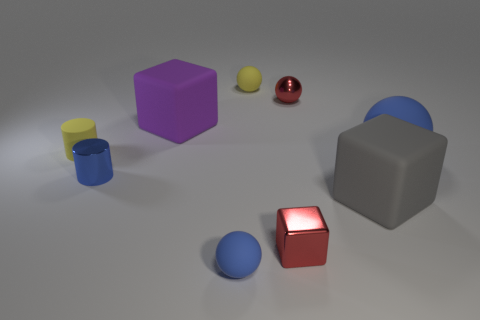Subtract all tiny red shiny cubes. How many cubes are left? 2 Subtract all purple blocks. How many blocks are left? 2 Subtract 2 cylinders. How many cylinders are left? 0 Add 1 cyan rubber blocks. How many objects exist? 10 Subtract all cylinders. How many objects are left? 7 Subtract all purple balls. How many blue cylinders are left? 1 Subtract all tiny shiny cylinders. Subtract all blue cylinders. How many objects are left? 7 Add 8 big gray matte things. How many big gray matte things are left? 9 Add 8 small shiny blocks. How many small shiny blocks exist? 9 Subtract 0 cyan cylinders. How many objects are left? 9 